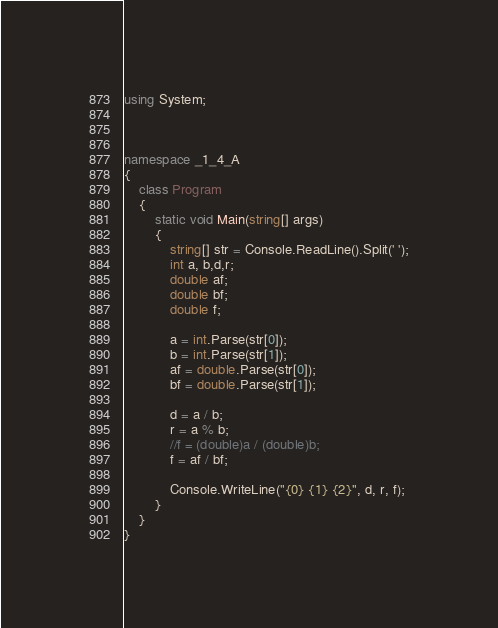<code> <loc_0><loc_0><loc_500><loc_500><_C#_>using System;



namespace _1_4_A
{
    class Program
    {
        static void Main(string[] args)
        {
            string[] str = Console.ReadLine().Split(' ');
            int a, b,d,r;
            double af;
            double bf;
            double f;

            a = int.Parse(str[0]);
            b = int.Parse(str[1]);
            af = double.Parse(str[0]);
            bf = double.Parse(str[1]);

            d = a / b;
            r = a % b;
            //f = (double)a / (double)b;
            f = af / bf;

            Console.WriteLine("{0} {1} {2}", d, r, f);
        }
    }
}

</code> 